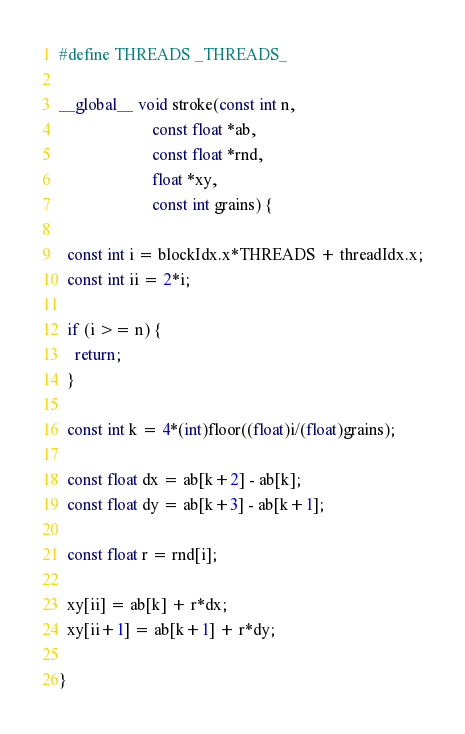<code> <loc_0><loc_0><loc_500><loc_500><_Cuda_>#define THREADS _THREADS_

__global__ void stroke(const int n,
                       const float *ab,
                       const float *rnd,
                       float *xy,
                       const int grains) {

  const int i = blockIdx.x*THREADS + threadIdx.x;
  const int ii = 2*i;

  if (i >= n) {
    return;
  }

  const int k = 4*(int)floor((float)i/(float)grains);

  const float dx = ab[k+2] - ab[k];
  const float dy = ab[k+3] - ab[k+1];

  const float r = rnd[i];

  xy[ii] = ab[k] + r*dx;
  xy[ii+1] = ab[k+1] + r*dy;

}

</code> 